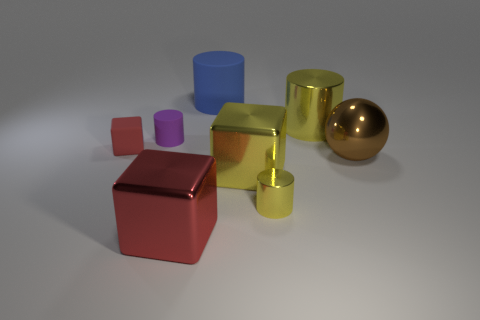Subtract all red shiny blocks. How many blocks are left? 2 Subtract all green blocks. How many yellow cylinders are left? 2 Add 1 small red rubber cylinders. How many objects exist? 9 Subtract all blue cylinders. How many cylinders are left? 3 Subtract all green cylinders. Subtract all cyan balls. How many cylinders are left? 4 Subtract all cubes. How many objects are left? 5 Subtract 1 purple cylinders. How many objects are left? 7 Subtract all small brown rubber objects. Subtract all spheres. How many objects are left? 7 Add 7 blue matte things. How many blue matte things are left? 8 Add 6 red things. How many red things exist? 8 